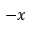<formula> <loc_0><loc_0><loc_500><loc_500>- x</formula> 